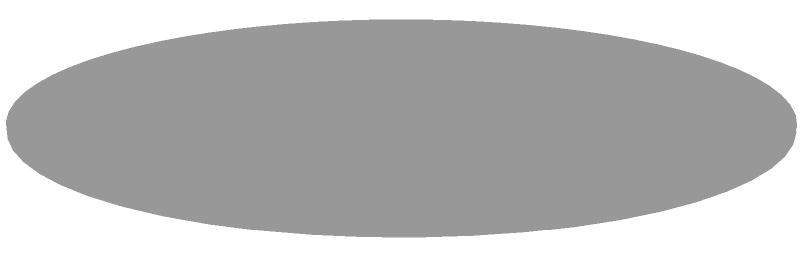As a hip-hop artist, you're interested in the physical properties of vinyl records for sampling. Model a standard 12-inch vinyl record as a cylinder. If the radius is 6 cm and the thickness is 0.1 cm, what is the volume of the record in cubic centimeters? Round your answer to two decimal places. To find the volume of the vinyl record modeled as a cylinder, we'll use the formula for the volume of a cylinder:

$$V = \pi r^2 h$$

Where:
$V$ is the volume
$r$ is the radius
$h$ is the height (thickness in this case)

Given:
$r = 6$ cm
$h = 0.1$ cm

Let's substitute these values into the formula:

$$V = \pi (6 \text{ cm})^2 (0.1 \text{ cm})$$

Simplifying:
$$V = \pi (36 \text{ cm}^2) (0.1 \text{ cm})$$
$$V = 3.6\pi \text{ cm}^3$$

Using $\pi \approx 3.14159$:

$$V \approx 3.6 \times 3.14159 \text{ cm}^3$$
$$V \approx 11.30972 \text{ cm}^3$$

Rounding to two decimal places:

$$V \approx 11.31 \text{ cm}^3$$
Answer: $11.31 \text{ cm}^3$ 